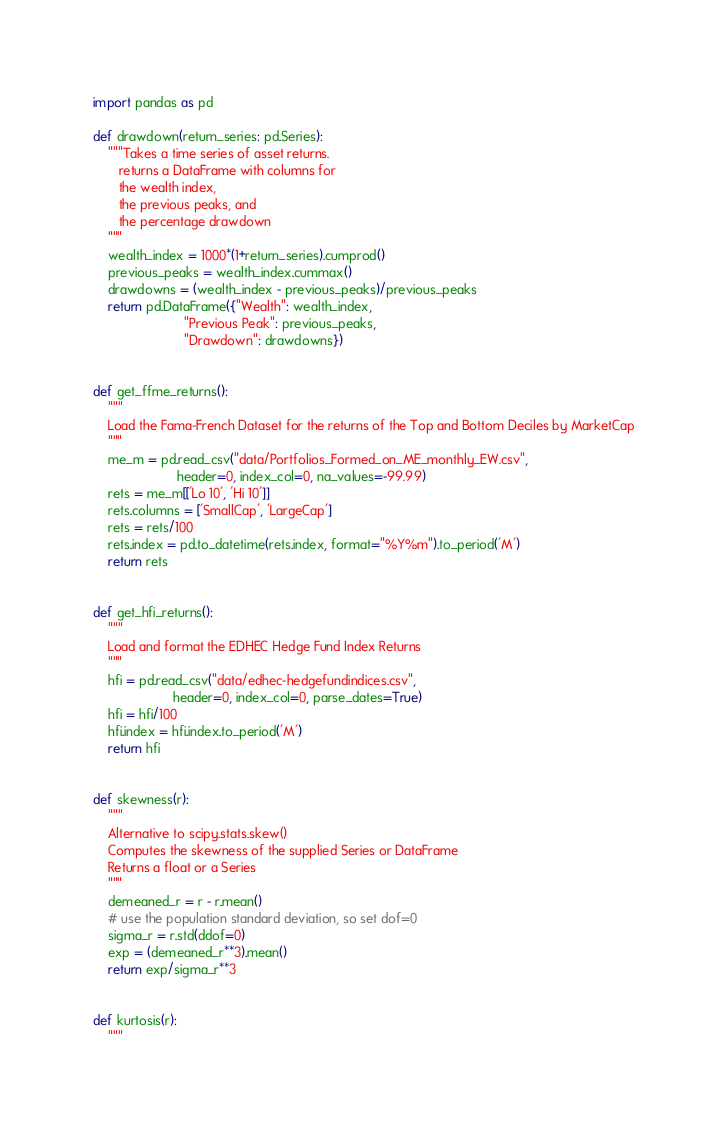Convert code to text. <code><loc_0><loc_0><loc_500><loc_500><_Python_>import pandas as pd

def drawdown(return_series: pd.Series):
    """Takes a time series of asset returns.
       returns a DataFrame with columns for
       the wealth index, 
       the previous peaks, and 
       the percentage drawdown
    """
    wealth_index = 1000*(1+return_series).cumprod()
    previous_peaks = wealth_index.cummax()
    drawdowns = (wealth_index - previous_peaks)/previous_peaks
    return pd.DataFrame({"Wealth": wealth_index, 
                         "Previous Peak": previous_peaks, 
                         "Drawdown": drawdowns})


def get_ffme_returns():
    """
    Load the Fama-French Dataset for the returns of the Top and Bottom Deciles by MarketCap
    """
    me_m = pd.read_csv("data/Portfolios_Formed_on_ME_monthly_EW.csv",
                       header=0, index_col=0, na_values=-99.99)
    rets = me_m[['Lo 10', 'Hi 10']]
    rets.columns = ['SmallCap', 'LargeCap']
    rets = rets/100
    rets.index = pd.to_datetime(rets.index, format="%Y%m").to_period('M')
    return rets


def get_hfi_returns():
    """
    Load and format the EDHEC Hedge Fund Index Returns
    """
    hfi = pd.read_csv("data/edhec-hedgefundindices.csv",
                      header=0, index_col=0, parse_dates=True)
    hfi = hfi/100
    hfi.index = hfi.index.to_period('M')
    return hfi


def skewness(r):
    """
    Alternative to scipy.stats.skew()
    Computes the skewness of the supplied Series or DataFrame
    Returns a float or a Series
    """
    demeaned_r = r - r.mean()
    # use the population standard deviation, so set dof=0
    sigma_r = r.std(ddof=0)
    exp = (demeaned_r**3).mean()
    return exp/sigma_r**3


def kurtosis(r):
    """</code> 